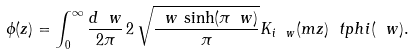<formula> <loc_0><loc_0><loc_500><loc_500>\phi ( z ) = \int _ { 0 } ^ { \infty } \frac { d \ w } { 2 \pi } \, 2 \, \sqrt { \frac { \ w \, \sinh ( \pi \ w ) } { \pi } } K _ { i \ w } ( m z ) \ t p h i ( \ w ) .</formula> 